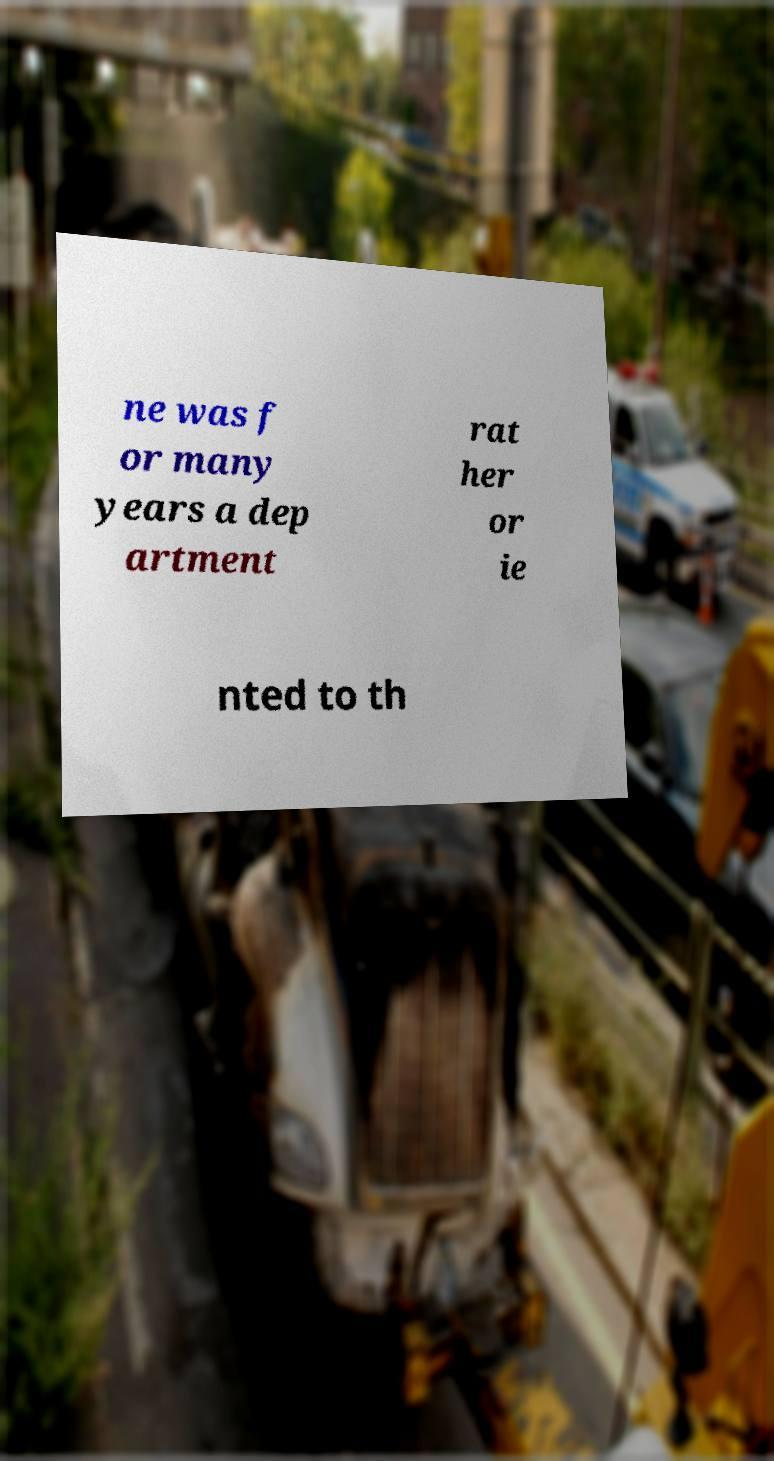Please read and relay the text visible in this image. What does it say? ne was f or many years a dep artment rat her or ie nted to th 